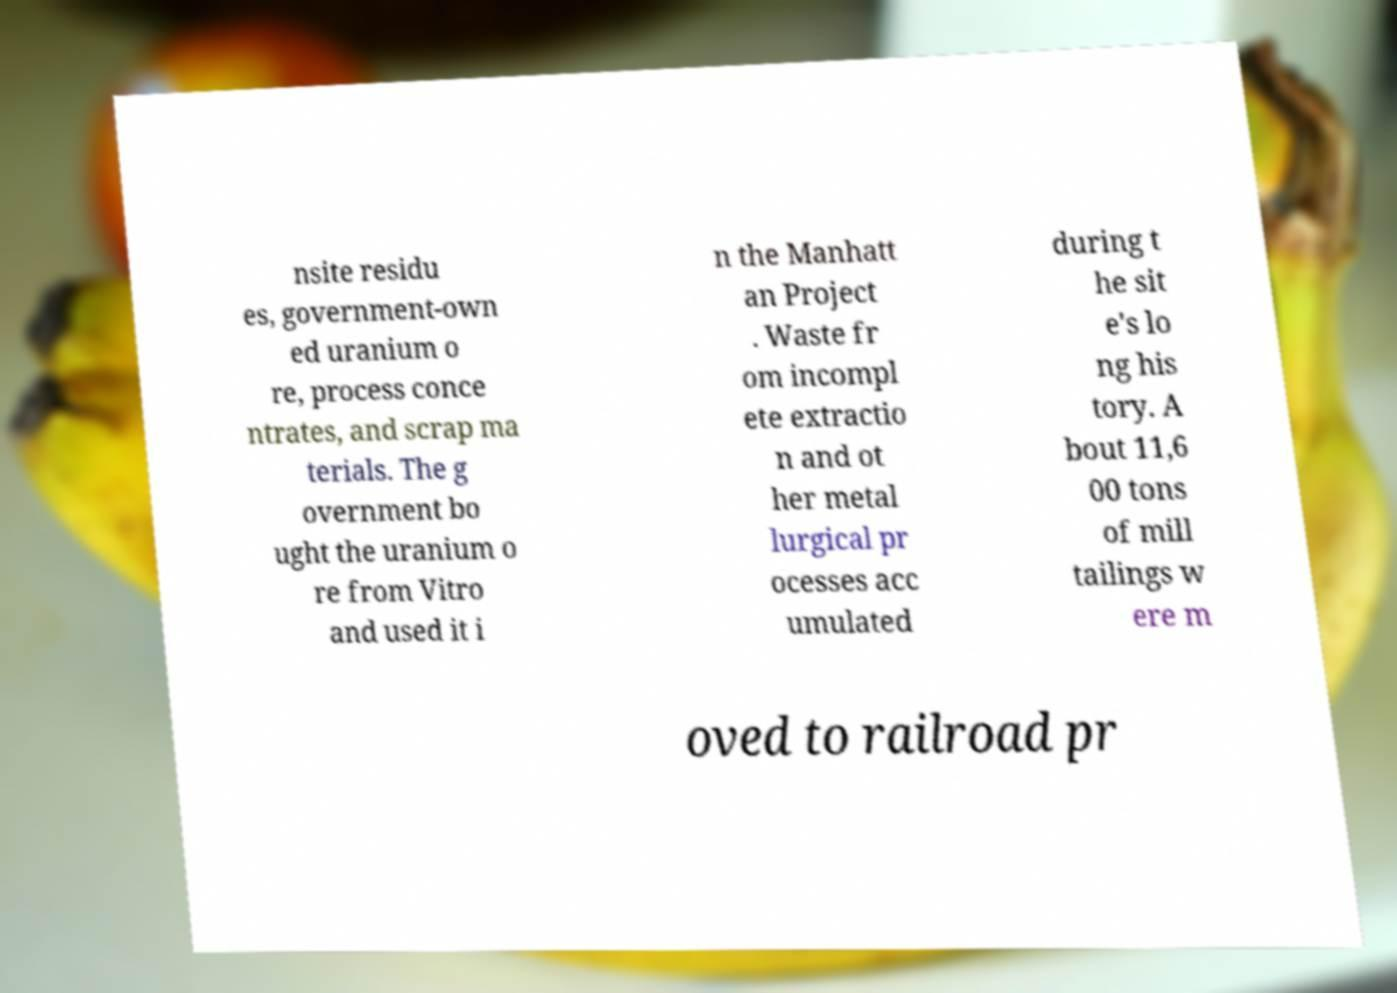There's text embedded in this image that I need extracted. Can you transcribe it verbatim? nsite residu es, government-own ed uranium o re, process conce ntrates, and scrap ma terials. The g overnment bo ught the uranium o re from Vitro and used it i n the Manhatt an Project . Waste fr om incompl ete extractio n and ot her metal lurgical pr ocesses acc umulated during t he sit e's lo ng his tory. A bout 11,6 00 tons of mill tailings w ere m oved to railroad pr 